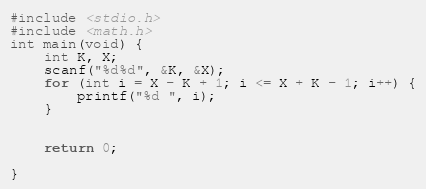<code> <loc_0><loc_0><loc_500><loc_500><_C_>#include <stdio.h>
#include <math.h>
int main(void) {
	int K, X;
	scanf("%d%d", &K, &X);
	for (int i = X - K + 1; i <= X + K - 1; i++) {
		printf("%d ", i);
	}


	return 0;

}</code> 